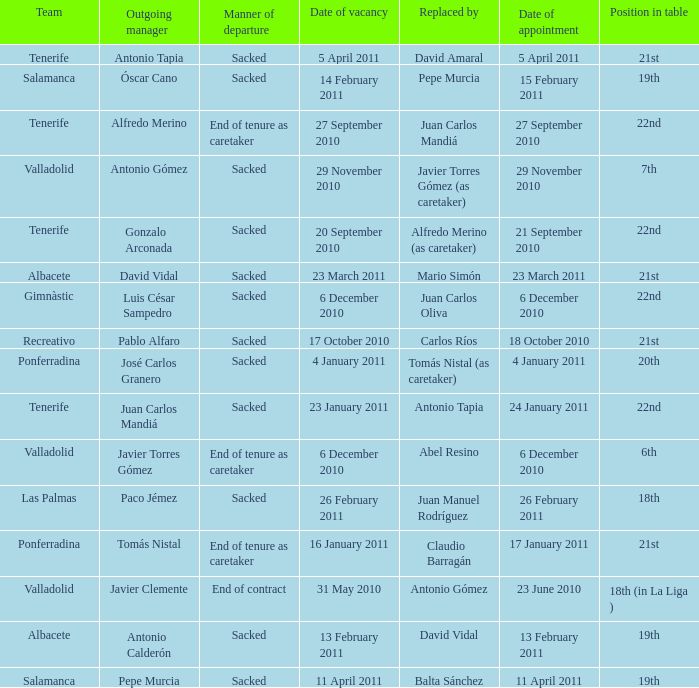Would you mind parsing the complete table? {'header': ['Team', 'Outgoing manager', 'Manner of departure', 'Date of vacancy', 'Replaced by', 'Date of appointment', 'Position in table'], 'rows': [['Tenerife', 'Antonio Tapia', 'Sacked', '5 April 2011', 'David Amaral', '5 April 2011', '21st'], ['Salamanca', 'Óscar Cano', 'Sacked', '14 February 2011', 'Pepe Murcia', '15 February 2011', '19th'], ['Tenerife', 'Alfredo Merino', 'End of tenure as caretaker', '27 September 2010', 'Juan Carlos Mandiá', '27 September 2010', '22nd'], ['Valladolid', 'Antonio Gómez', 'Sacked', '29 November 2010', 'Javier Torres Gómez (as caretaker)', '29 November 2010', '7th'], ['Tenerife', 'Gonzalo Arconada', 'Sacked', '20 September 2010', 'Alfredo Merino (as caretaker)', '21 September 2010', '22nd'], ['Albacete', 'David Vidal', 'Sacked', '23 March 2011', 'Mario Simón', '23 March 2011', '21st'], ['Gimnàstic', 'Luis César Sampedro', 'Sacked', '6 December 2010', 'Juan Carlos Oliva', '6 December 2010', '22nd'], ['Recreativo', 'Pablo Alfaro', 'Sacked', '17 October 2010', 'Carlos Ríos', '18 October 2010', '21st'], ['Ponferradina', 'José Carlos Granero', 'Sacked', '4 January 2011', 'Tomás Nistal (as caretaker)', '4 January 2011', '20th'], ['Tenerife', 'Juan Carlos Mandiá', 'Sacked', '23 January 2011', 'Antonio Tapia', '24 January 2011', '22nd'], ['Valladolid', 'Javier Torres Gómez', 'End of tenure as caretaker', '6 December 2010', 'Abel Resino', '6 December 2010', '6th'], ['Las Palmas', 'Paco Jémez', 'Sacked', '26 February 2011', 'Juan Manuel Rodríguez', '26 February 2011', '18th'], ['Ponferradina', 'Tomás Nistal', 'End of tenure as caretaker', '16 January 2011', 'Claudio Barragán', '17 January 2011', '21st'], ['Valladolid', 'Javier Clemente', 'End of contract', '31 May 2010', 'Antonio Gómez', '23 June 2010', '18th (in La Liga )'], ['Albacete', 'Antonio Calderón', 'Sacked', '13 February 2011', 'David Vidal', '13 February 2011', '19th'], ['Salamanca', 'Pepe Murcia', 'Sacked', '11 April 2011', 'Balta Sánchez', '11 April 2011', '19th']]} What was the manner of departure for the appointment date of 21 september 2010 Sacked. 